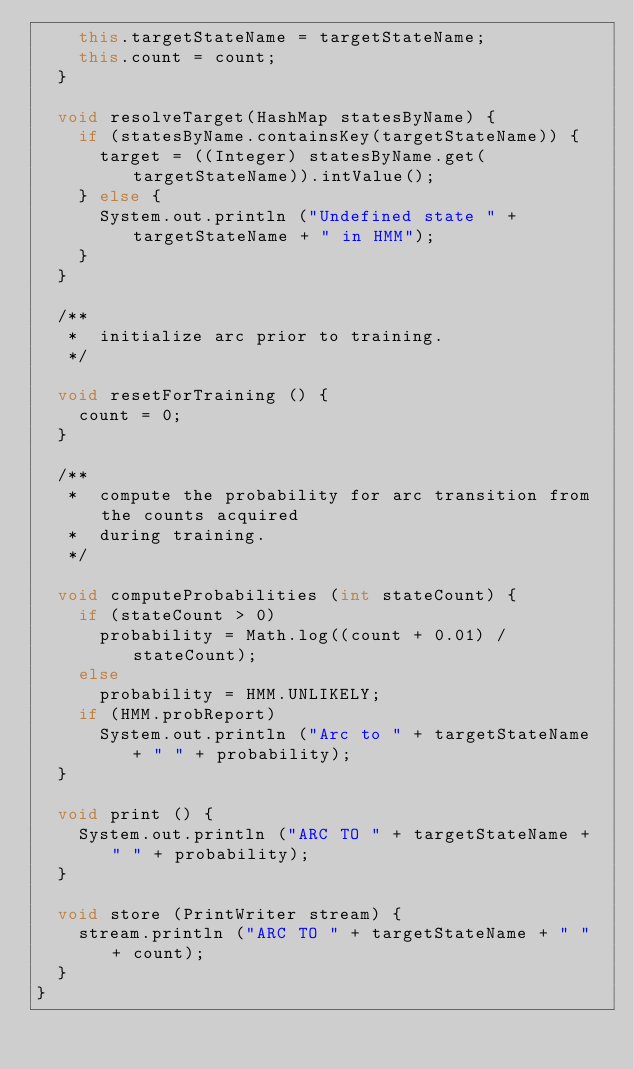Convert code to text. <code><loc_0><loc_0><loc_500><loc_500><_Java_>		this.targetStateName = targetStateName;
		this.count = count;
	}

	void resolveTarget(HashMap statesByName) {
		if (statesByName.containsKey(targetStateName)) {
			target = ((Integer) statesByName.get(targetStateName)).intValue();
		} else {
			System.out.println ("Undefined state " + targetStateName + " in HMM");
		}
	}

	/**
	 *  initialize arc prior to training.
	 */

	void resetForTraining () {
		count = 0;
	}

	/**
	 *  compute the probability for arc transition from the counts acquired
	 *  during training.
	 */

	void computeProbabilities (int stateCount) {
		if (stateCount > 0)
			probability = Math.log((count + 0.01) / stateCount);
		else
			probability = HMM.UNLIKELY;
		if (HMM.probReport)
			System.out.println ("Arc to " + targetStateName + " " + probability);
	}

	void print () {
		System.out.println ("ARC TO " + targetStateName + " " + probability);
	}

	void store (PrintWriter stream) {
		stream.println ("ARC TO " + targetStateName + " " + count);
	}
}

</code> 